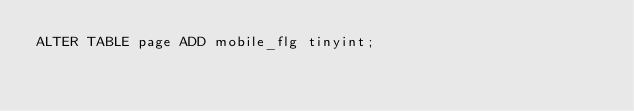<code> <loc_0><loc_0><loc_500><loc_500><_SQL_>ALTER TABLE page ADD mobile_flg tinyint;</code> 